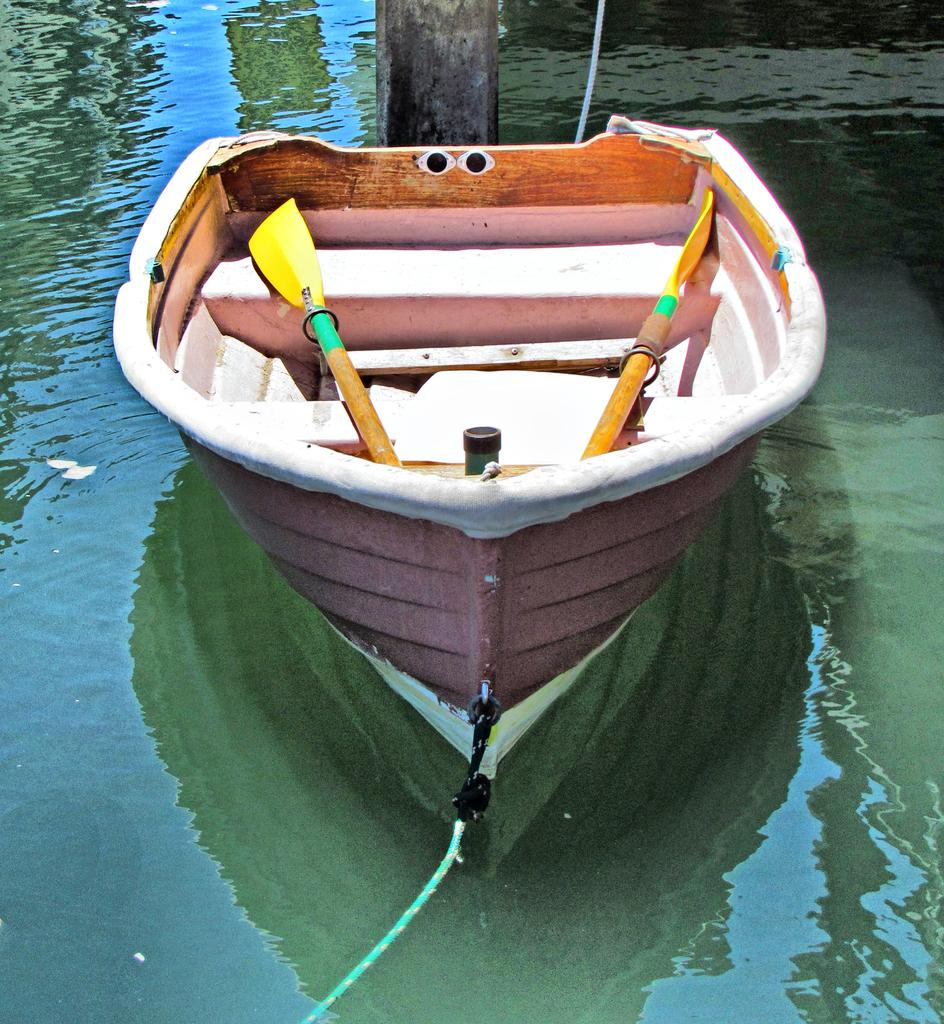What is the main subject of the image? The main subject of the image is a boat. What can be seen inside the boat? There are canoe paddles in the boat. What is visible at the bottom of the image? There is water visible at the bottom of the image. What type of profit can be seen in the image? There is no mention of profit in the image; it features a boat with canoe paddles and water. How many chickens are present in the image? There are no chickens present in the image. 